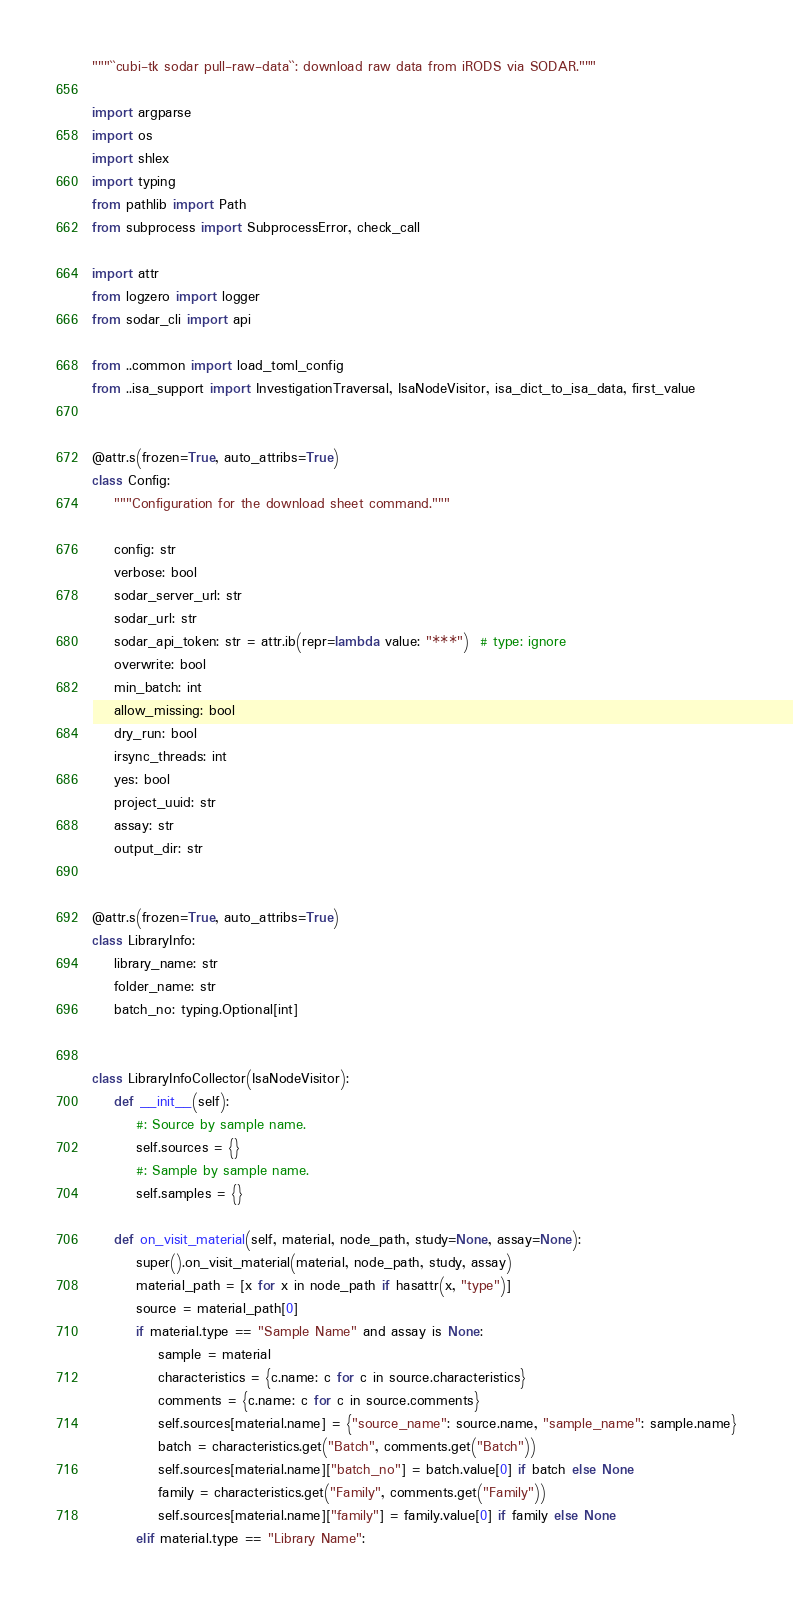Convert code to text. <code><loc_0><loc_0><loc_500><loc_500><_Python_>"""``cubi-tk sodar pull-raw-data``: download raw data from iRODS via SODAR."""

import argparse
import os
import shlex
import typing
from pathlib import Path
from subprocess import SubprocessError, check_call

import attr
from logzero import logger
from sodar_cli import api

from ..common import load_toml_config
from ..isa_support import InvestigationTraversal, IsaNodeVisitor, isa_dict_to_isa_data, first_value


@attr.s(frozen=True, auto_attribs=True)
class Config:
    """Configuration for the download sheet command."""

    config: str
    verbose: bool
    sodar_server_url: str
    sodar_url: str
    sodar_api_token: str = attr.ib(repr=lambda value: "***")  # type: ignore
    overwrite: bool
    min_batch: int
    allow_missing: bool
    dry_run: bool
    irsync_threads: int
    yes: bool
    project_uuid: str
    assay: str
    output_dir: str


@attr.s(frozen=True, auto_attribs=True)
class LibraryInfo:
    library_name: str
    folder_name: str
    batch_no: typing.Optional[int]


class LibraryInfoCollector(IsaNodeVisitor):
    def __init__(self):
        #: Source by sample name.
        self.sources = {}
        #: Sample by sample name.
        self.samples = {}

    def on_visit_material(self, material, node_path, study=None, assay=None):
        super().on_visit_material(material, node_path, study, assay)
        material_path = [x for x in node_path if hasattr(x, "type")]
        source = material_path[0]
        if material.type == "Sample Name" and assay is None:
            sample = material
            characteristics = {c.name: c for c in source.characteristics}
            comments = {c.name: c for c in source.comments}
            self.sources[material.name] = {"source_name": source.name, "sample_name": sample.name}
            batch = characteristics.get("Batch", comments.get("Batch"))
            self.sources[material.name]["batch_no"] = batch.value[0] if batch else None
            family = characteristics.get("Family", comments.get("Family"))
            self.sources[material.name]["family"] = family.value[0] if family else None
        elif material.type == "Library Name":</code> 